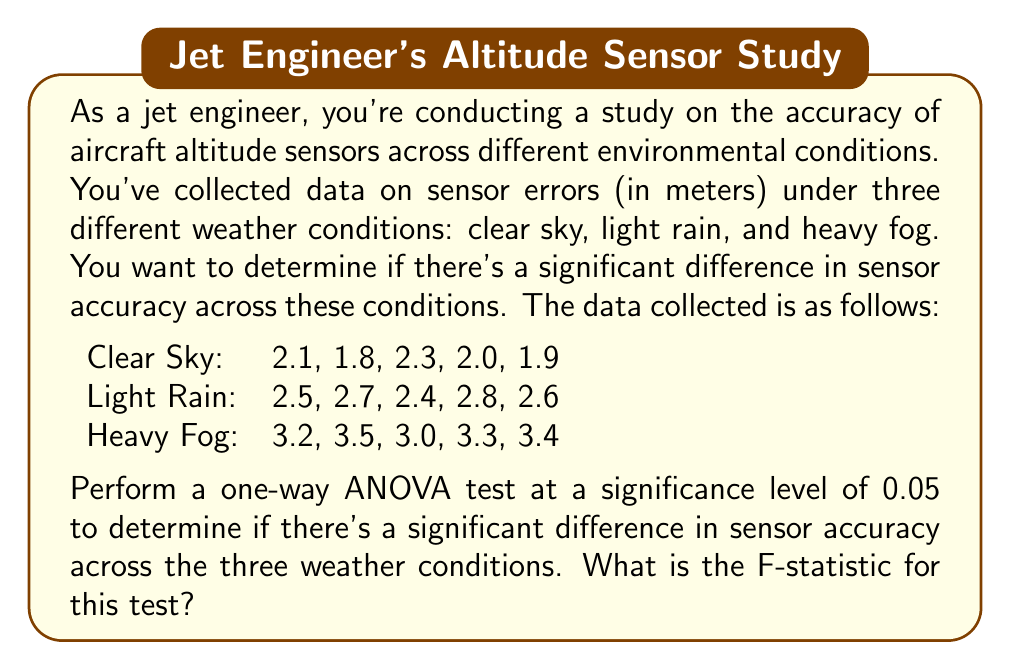Teach me how to tackle this problem. To perform a one-way ANOVA test, we need to follow these steps:

1. Calculate the total sum of squares (SST)
2. Calculate the sum of squares between groups (SSB)
3. Calculate the sum of squares within groups (SSW)
4. Calculate the degrees of freedom
5. Calculate the mean squares
6. Calculate the F-statistic

Step 1: Calculate the grand mean and SST

Grand mean: $\bar{X} = \frac{2.1 + 1.8 + ... + 3.4}{15} = 2.63$

SST = $\sum_{i=1}^{n} (X_i - \bar{X})^2$
    = $(2.1 - 2.63)^2 + (1.8 - 2.63)^2 + ... + (3.4 - 2.63)^2$
    = 4.374

Step 2: Calculate SSB

Group means:
Clear Sky: $\bar{X}_1 = 2.02$
Light Rain: $\bar{X}_2 = 2.60$
Heavy Fog: $\bar{X}_3 = 3.28$

SSB = $n_1(\bar{X}_1 - \bar{X})^2 + n_2(\bar{X}_2 - \bar{X})^2 + n_3(\bar{X}_3 - \bar{X})^2$
    = $5(2.02 - 2.63)^2 + 5(2.60 - 2.63)^2 + 5(3.28 - 2.63)^2$
    = 4.0562

Step 3: Calculate SSW

SSW = SST - SSB = 4.374 - 4.0562 = 0.3178

Step 4: Calculate degrees of freedom

df(between) = k - 1 = 3 - 1 = 2 (k is the number of groups)
df(within) = N - k = 15 - 3 = 12 (N is the total number of observations)

Step 5: Calculate mean squares

MSB = SSB / df(between) = 4.0562 / 2 = 2.0281
MSW = SSW / df(within) = 0.3178 / 12 = 0.0265

Step 6: Calculate F-statistic

F = MSB / MSW = 2.0281 / 0.0265 = 76.53
Answer: The F-statistic for this one-way ANOVA test is approximately 76.53. 